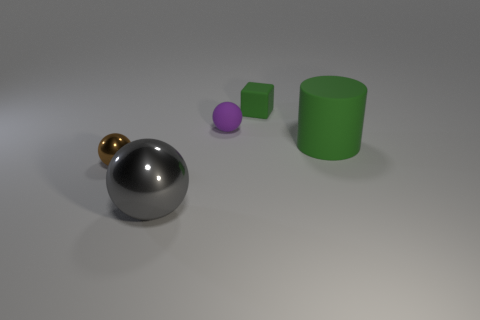What can you infer about the material properties of the objects from their appearance? Based on the way the light interacts with the objects, we can infer their material properties. The large gray sphere and the small golden sphere appear to be metallic due to their reflective surfaces and sharp highlights. The purple ball and green objects exhibit a matte finish, suggesting they're likely made of rubber or a similar non-reflective material. The shadows and reflections give clues about the texture and finish of each object. 